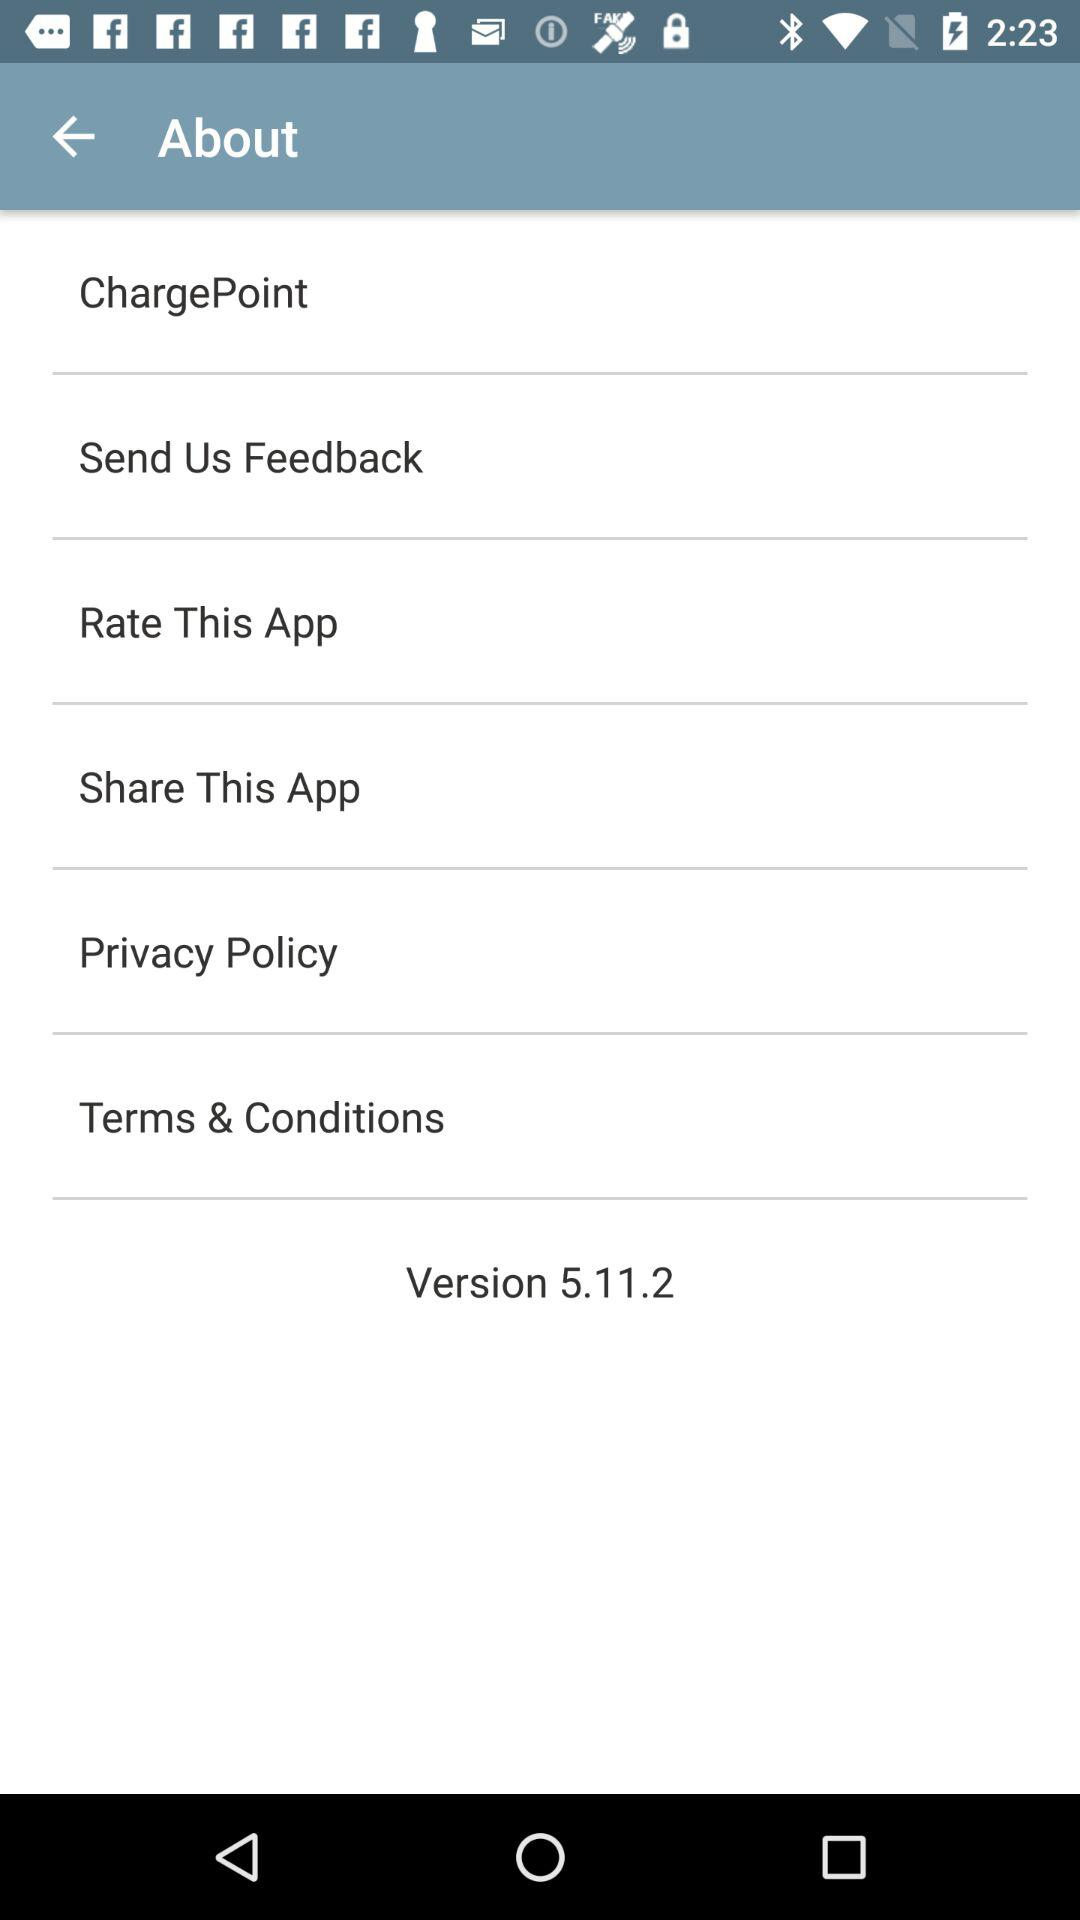What is the version number? The version number is 5.11.2. 